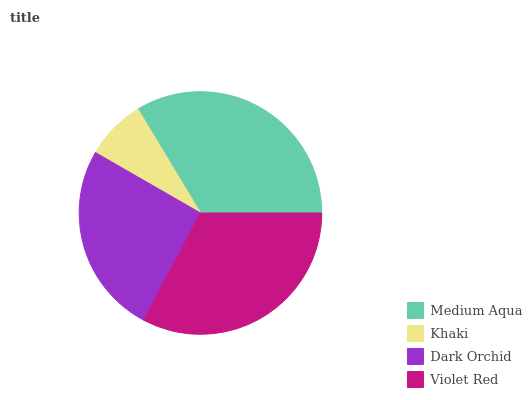Is Khaki the minimum?
Answer yes or no. Yes. Is Medium Aqua the maximum?
Answer yes or no. Yes. Is Dark Orchid the minimum?
Answer yes or no. No. Is Dark Orchid the maximum?
Answer yes or no. No. Is Dark Orchid greater than Khaki?
Answer yes or no. Yes. Is Khaki less than Dark Orchid?
Answer yes or no. Yes. Is Khaki greater than Dark Orchid?
Answer yes or no. No. Is Dark Orchid less than Khaki?
Answer yes or no. No. Is Violet Red the high median?
Answer yes or no. Yes. Is Dark Orchid the low median?
Answer yes or no. Yes. Is Medium Aqua the high median?
Answer yes or no. No. Is Khaki the low median?
Answer yes or no. No. 